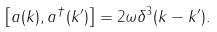Convert formula to latex. <formula><loc_0><loc_0><loc_500><loc_500>\left [ a ( k ) , a ^ { \dag } ( k ^ { \prime } ) \right ] = 2 \omega \delta ^ { 3 } ( k - k ^ { \prime } ) .</formula> 